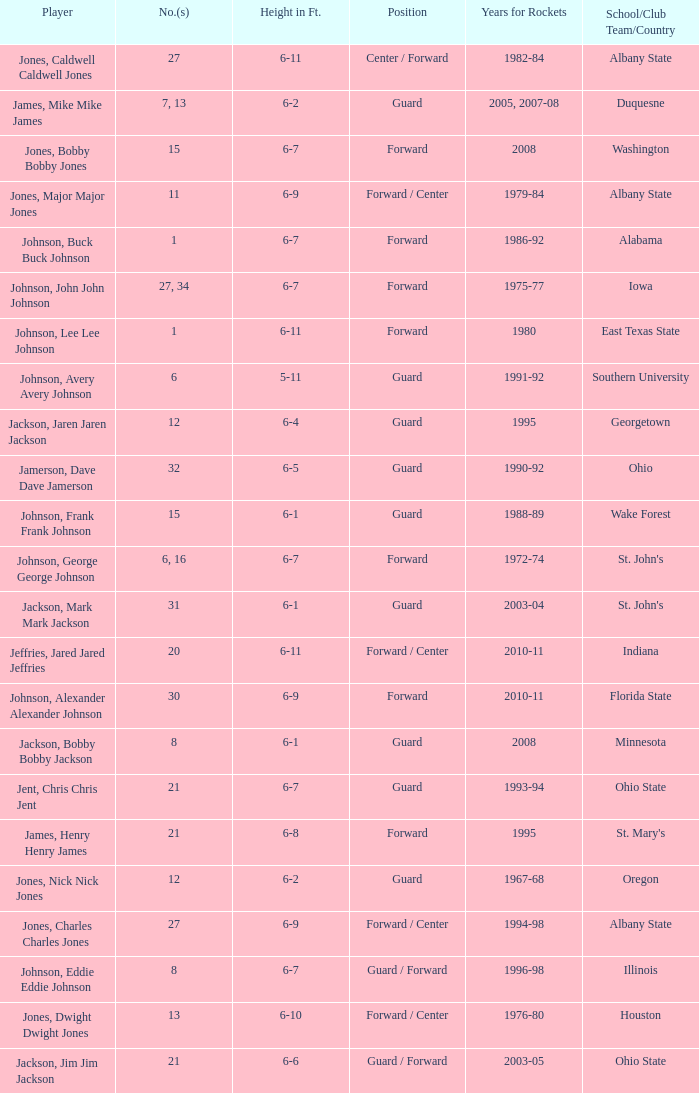Which player who played for the Rockets for the years 1986-92? Johnson, Buck Buck Johnson. 